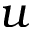<formula> <loc_0><loc_0><loc_500><loc_500>u</formula> 